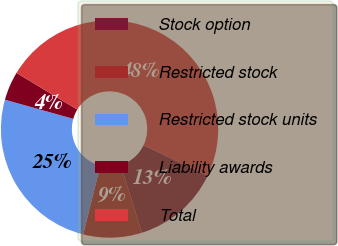Convert chart. <chart><loc_0><loc_0><loc_500><loc_500><pie_chart><fcel>Stock option<fcel>Restricted stock<fcel>Restricted stock units<fcel>Liability awards<fcel>Total<nl><fcel>13.12%<fcel>8.71%<fcel>25.44%<fcel>4.29%<fcel>48.44%<nl></chart> 